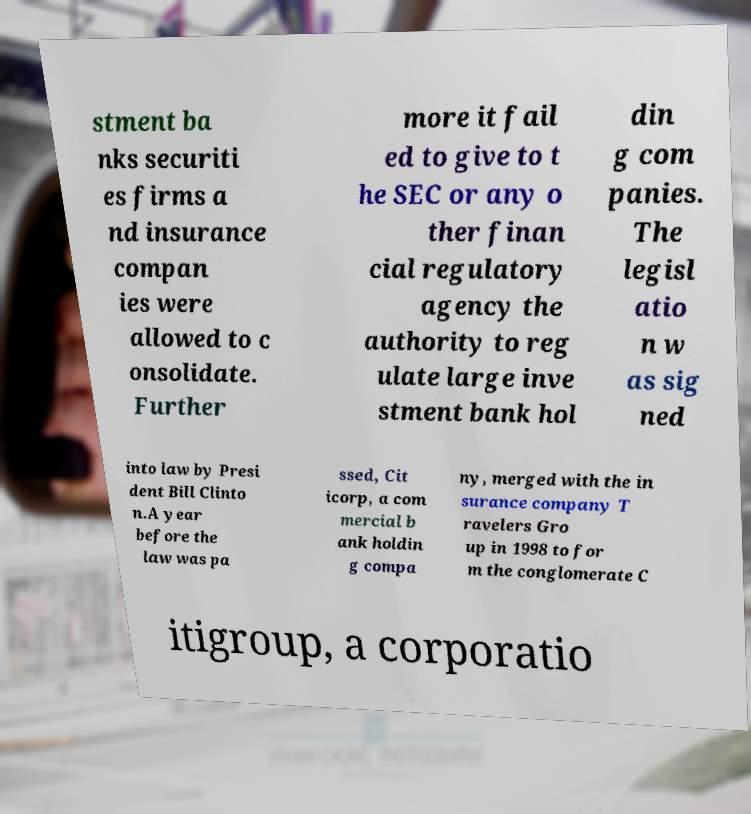Could you extract and type out the text from this image? stment ba nks securiti es firms a nd insurance compan ies were allowed to c onsolidate. Further more it fail ed to give to t he SEC or any o ther finan cial regulatory agency the authority to reg ulate large inve stment bank hol din g com panies. The legisl atio n w as sig ned into law by Presi dent Bill Clinto n.A year before the law was pa ssed, Cit icorp, a com mercial b ank holdin g compa ny, merged with the in surance company T ravelers Gro up in 1998 to for m the conglomerate C itigroup, a corporatio 